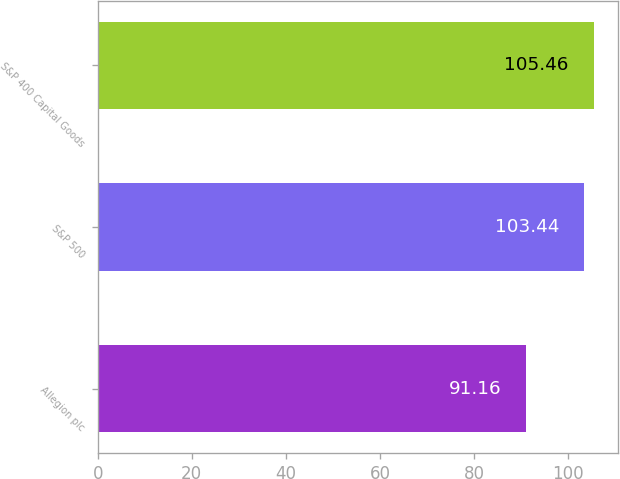Convert chart. <chart><loc_0><loc_0><loc_500><loc_500><bar_chart><fcel>Allegion plc<fcel>S&P 500<fcel>S&P 400 Capital Goods<nl><fcel>91.16<fcel>103.44<fcel>105.46<nl></chart> 